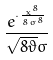Convert formula to latex. <formula><loc_0><loc_0><loc_500><loc_500>\frac { e ^ { \cdot \frac { x ^ { 8 } } { 8 \sigma ^ { 8 } } } } { \sqrt { 8 \vartheta } \sigma }</formula> 